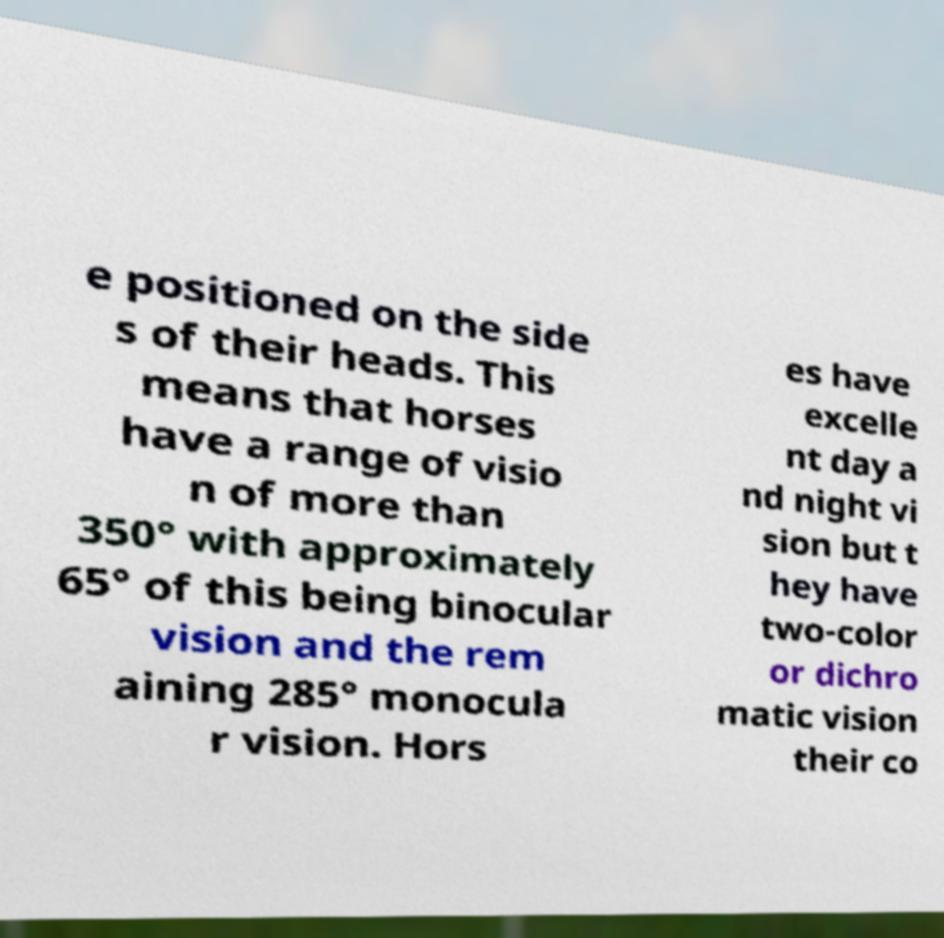Could you assist in decoding the text presented in this image and type it out clearly? e positioned on the side s of their heads. This means that horses have a range of visio n of more than 350° with approximately 65° of this being binocular vision and the rem aining 285° monocula r vision. Hors es have excelle nt day a nd night vi sion but t hey have two-color or dichro matic vision their co 